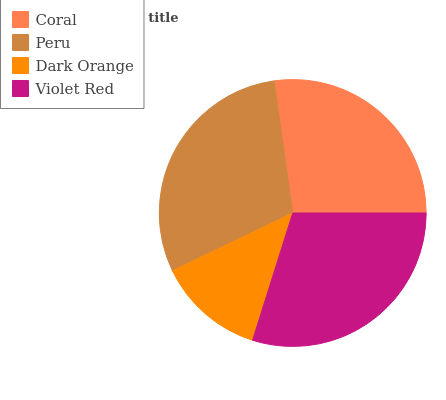Is Dark Orange the minimum?
Answer yes or no. Yes. Is Peru the maximum?
Answer yes or no. Yes. Is Peru the minimum?
Answer yes or no. No. Is Dark Orange the maximum?
Answer yes or no. No. Is Peru greater than Dark Orange?
Answer yes or no. Yes. Is Dark Orange less than Peru?
Answer yes or no. Yes. Is Dark Orange greater than Peru?
Answer yes or no. No. Is Peru less than Dark Orange?
Answer yes or no. No. Is Violet Red the high median?
Answer yes or no. Yes. Is Coral the low median?
Answer yes or no. Yes. Is Coral the high median?
Answer yes or no. No. Is Peru the low median?
Answer yes or no. No. 